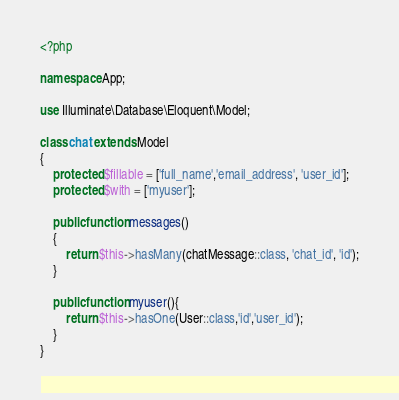Convert code to text. <code><loc_0><loc_0><loc_500><loc_500><_PHP_><?php

namespace App;

use Illuminate\Database\Eloquent\Model;

class chat extends Model
{
    protected $fillable = ['full_name','email_address', 'user_id'];
    protected $with = ['myuser'];

    public function messages()
    {
        return $this->hasMany(chatMessage::class, 'chat_id', 'id');
    }

    public function myuser(){
        return $this->hasOne(User::class,'id','user_id');
    }
}
</code> 